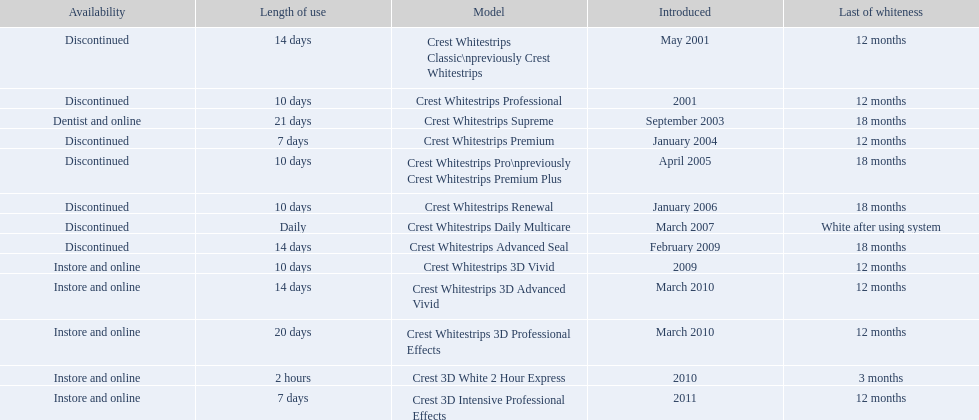Which of these products are discontinued? Crest Whitestrips Classic\npreviously Crest Whitestrips, Crest Whitestrips Professional, Crest Whitestrips Premium, Crest Whitestrips Pro\npreviously Crest Whitestrips Premium Plus, Crest Whitestrips Renewal, Crest Whitestrips Daily Multicare, Crest Whitestrips Advanced Seal. Which of these products have a 14 day length of use? Crest Whitestrips Classic\npreviously Crest Whitestrips, Crest Whitestrips Advanced Seal. Which of these products was introduced in 2009? Crest Whitestrips Advanced Seal. 